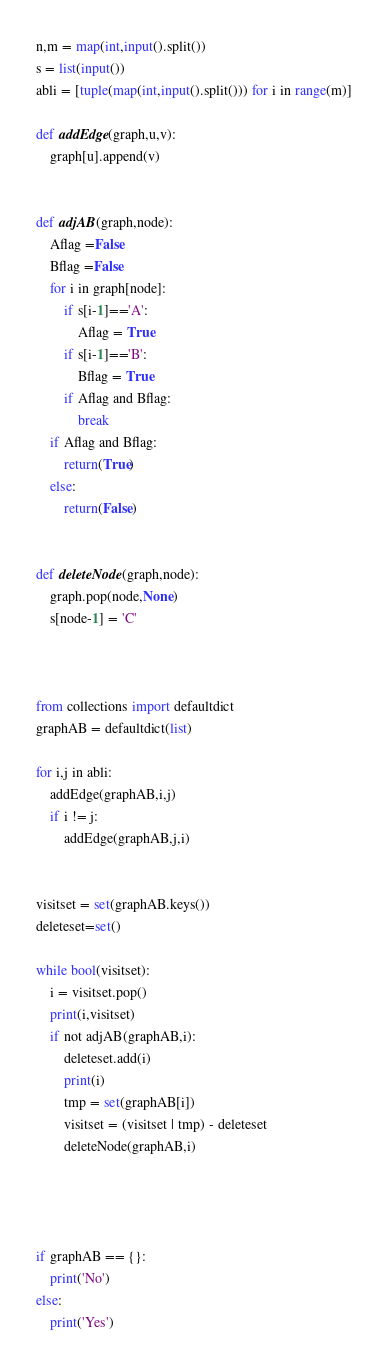<code> <loc_0><loc_0><loc_500><loc_500><_Python_>n,m = map(int,input().split())
s = list(input())
abli = [tuple(map(int,input().split())) for i in range(m)]

def addEdge(graph,u,v):
    graph[u].append(v)


def adjAB(graph,node):
    Aflag =False
    Bflag =False
    for i in graph[node]:
        if s[i-1]=='A':
            Aflag = True
        if s[i-1]=='B':
            Bflag = True
        if Aflag and Bflag:
            break
    if Aflag and Bflag:
        return(True)
    else:
        return(False)


def deleteNode(graph,node):
    graph.pop(node,None)
    s[node-1] = 'C'
        


from collections import defaultdict
graphAB = defaultdict(list)

for i,j in abli:
    addEdge(graphAB,i,j)
    if i != j:
        addEdge(graphAB,j,i)


visitset = set(graphAB.keys())
deleteset=set()

while bool(visitset):
    i = visitset.pop()
    print(i,visitset)
    if not adjAB(graphAB,i):
        deleteset.add(i)
        print(i)
        tmp = set(graphAB[i])
        visitset = (visitset | tmp) - deleteset
        deleteNode(graphAB,i)




if graphAB == {}:
    print('No')
else:
    print('Yes')



</code> 